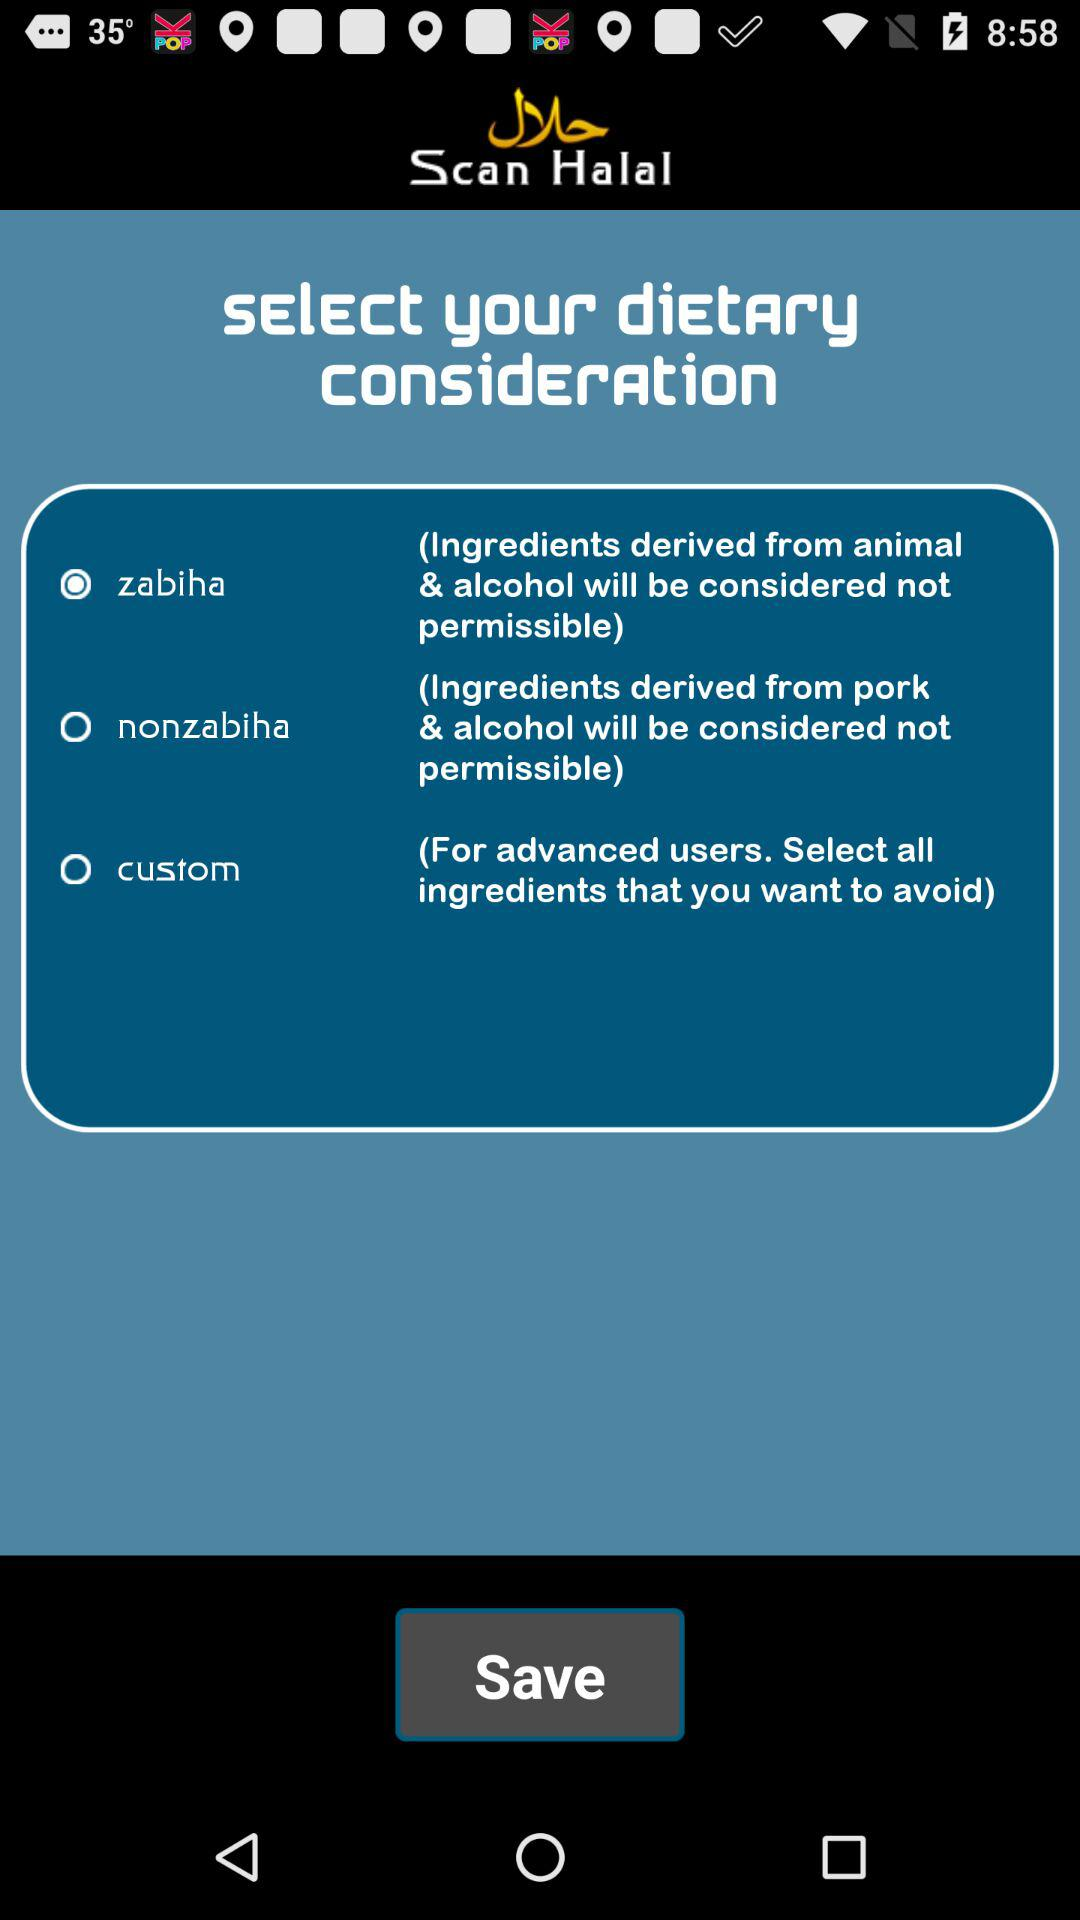How many dietary consideration options are there?
Answer the question using a single word or phrase. 3 